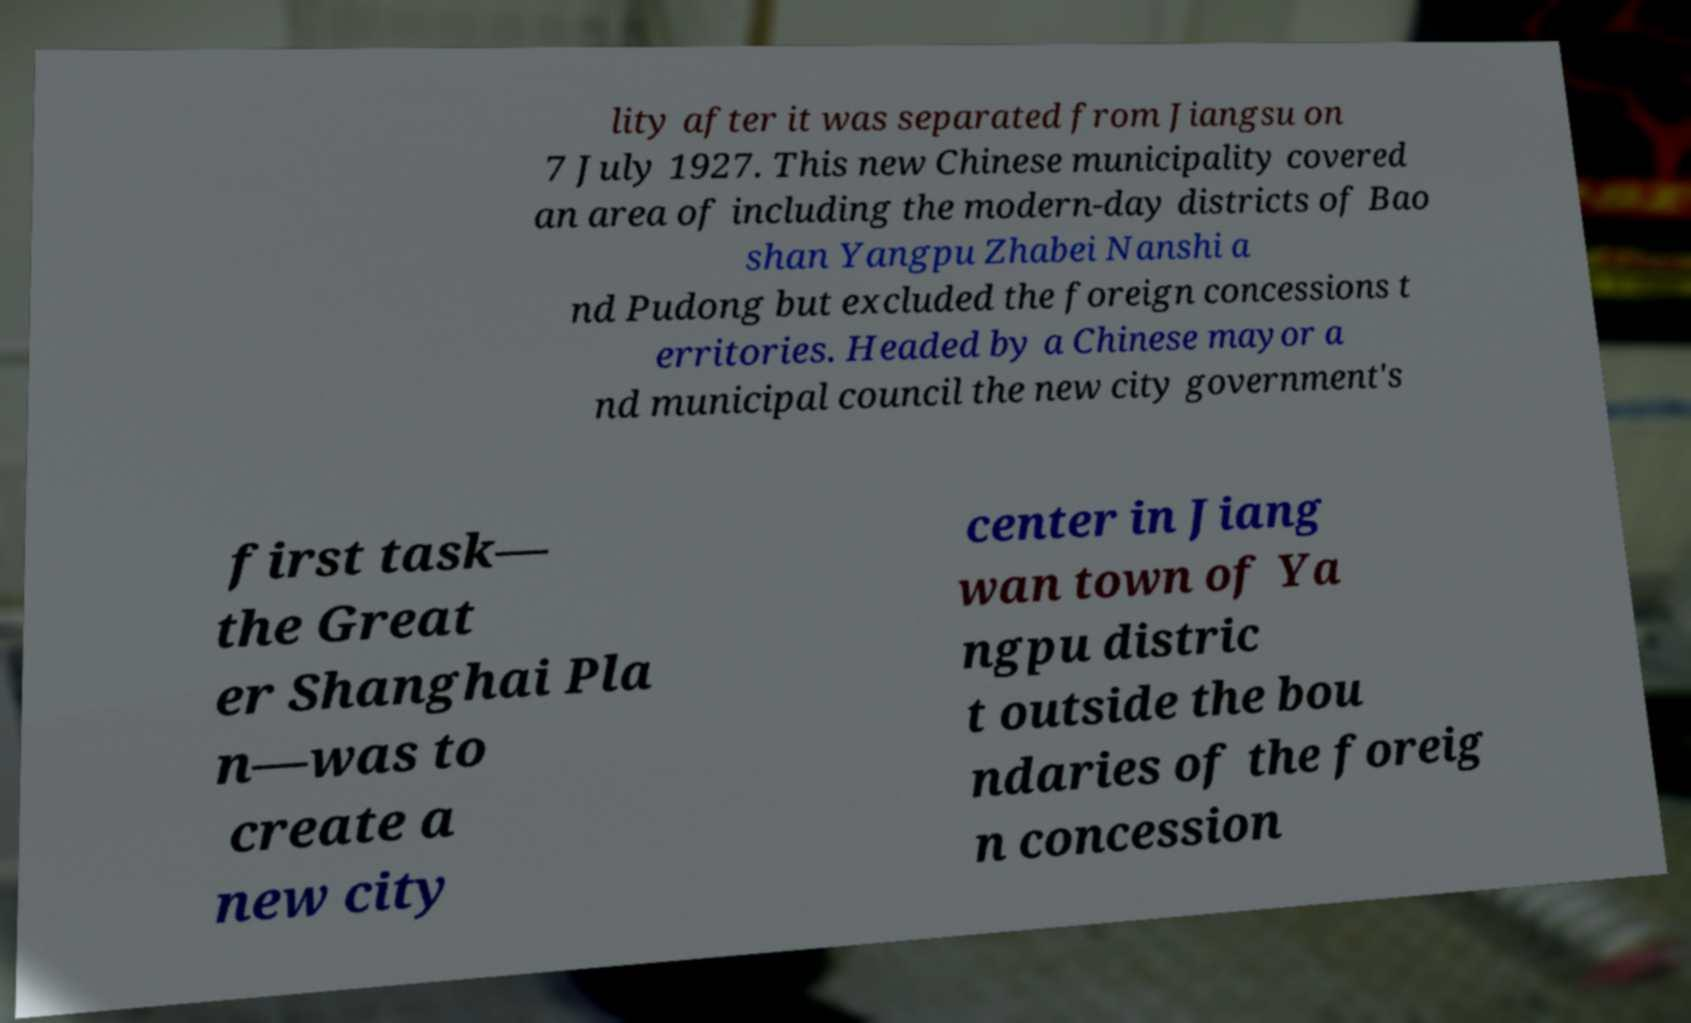What messages or text are displayed in this image? I need them in a readable, typed format. lity after it was separated from Jiangsu on 7 July 1927. This new Chinese municipality covered an area of including the modern-day districts of Bao shan Yangpu Zhabei Nanshi a nd Pudong but excluded the foreign concessions t erritories. Headed by a Chinese mayor a nd municipal council the new city government's first task— the Great er Shanghai Pla n—was to create a new city center in Jiang wan town of Ya ngpu distric t outside the bou ndaries of the foreig n concession 